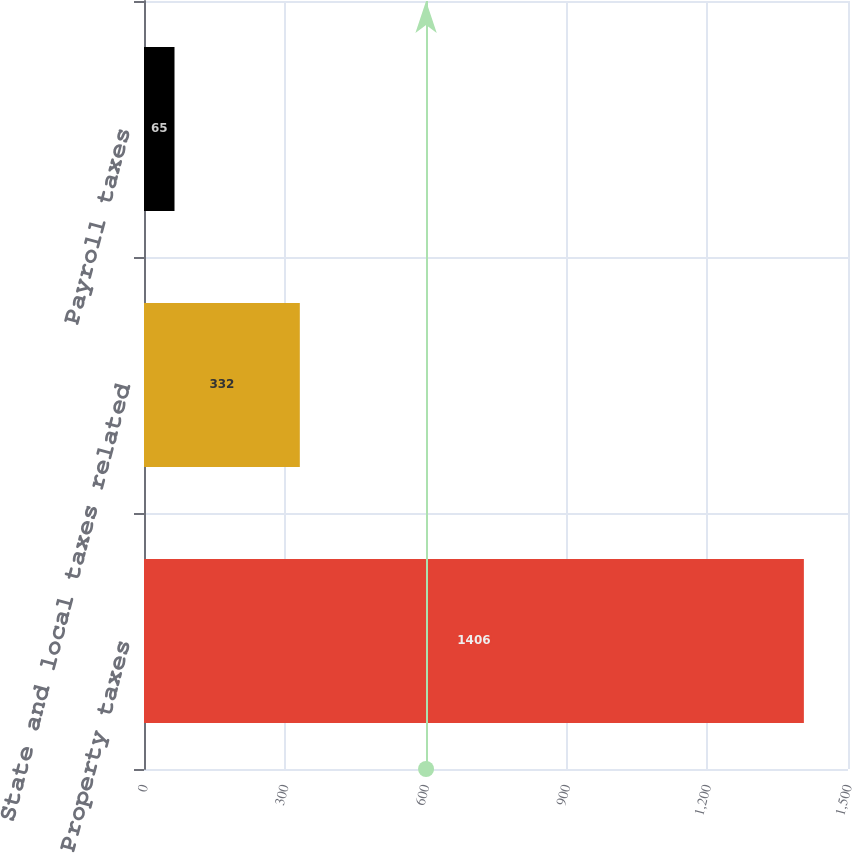Convert chart. <chart><loc_0><loc_0><loc_500><loc_500><bar_chart><fcel>Property taxes<fcel>State and local taxes related<fcel>Payroll taxes<nl><fcel>1406<fcel>332<fcel>65<nl></chart> 